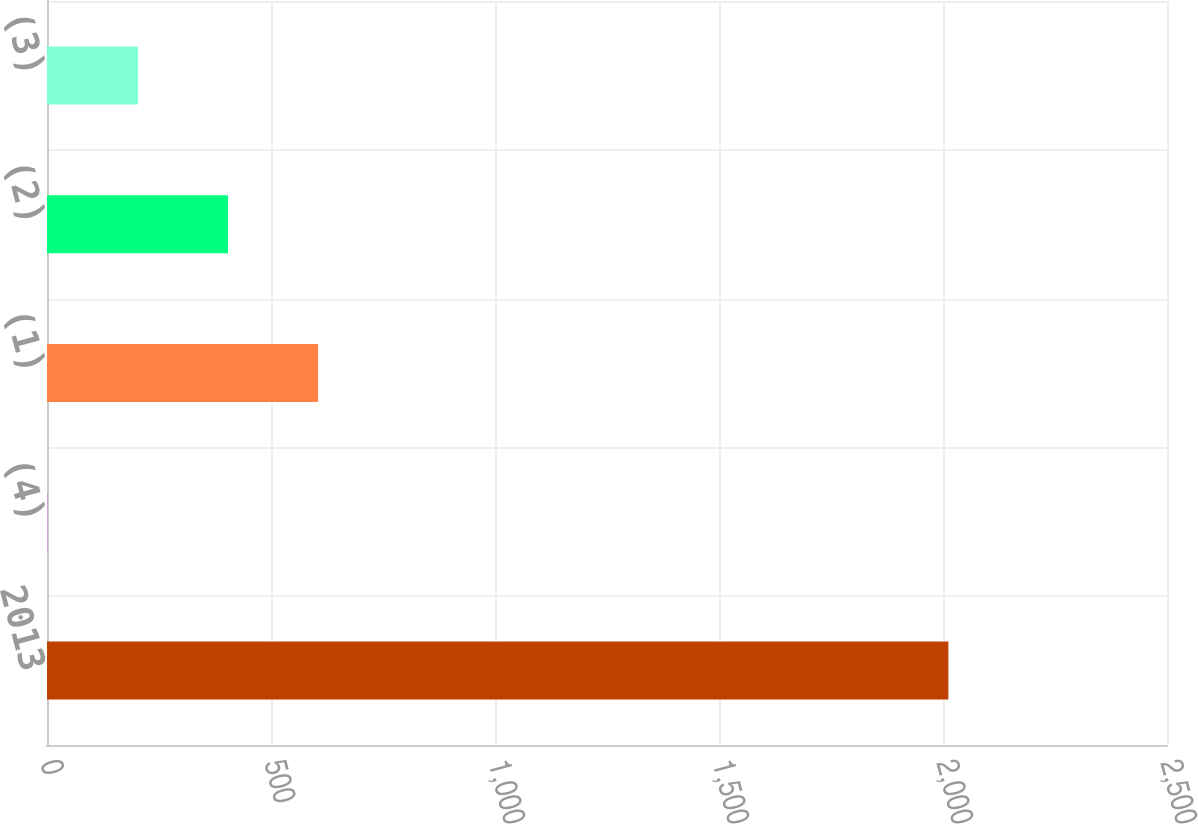Convert chart. <chart><loc_0><loc_0><loc_500><loc_500><bar_chart><fcel>2013<fcel>(4)<fcel>(1)<fcel>(2)<fcel>(3)<nl><fcel>2012<fcel>2<fcel>605<fcel>404<fcel>203<nl></chart> 